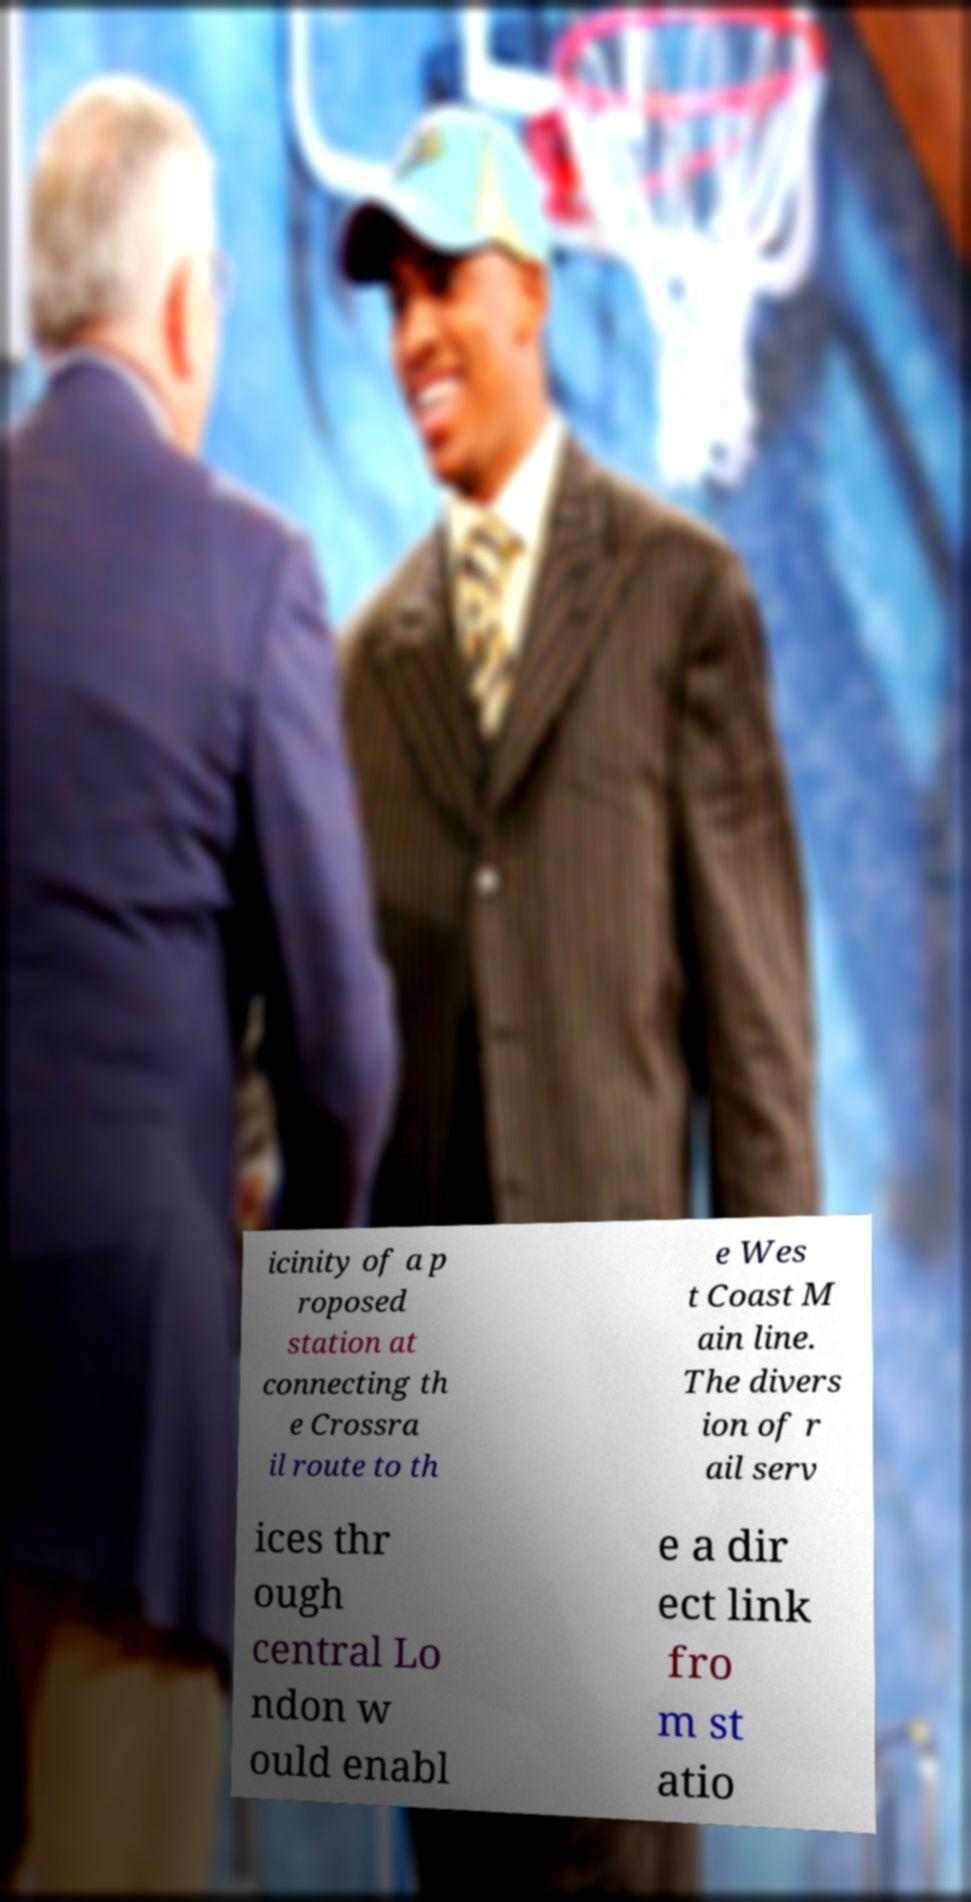Please identify and transcribe the text found in this image. icinity of a p roposed station at connecting th e Crossra il route to th e Wes t Coast M ain line. The divers ion of r ail serv ices thr ough central Lo ndon w ould enabl e a dir ect link fro m st atio 